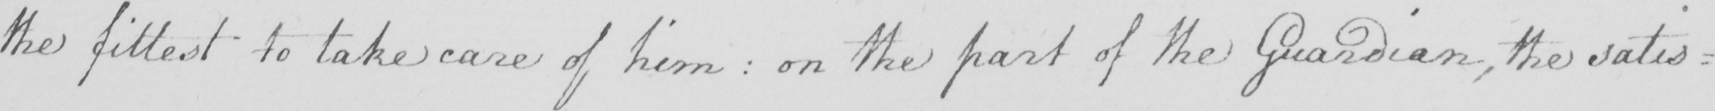Transcribe the text shown in this historical manuscript line. the fittest to take care of him :  on the part of the Guardian , the satis= 